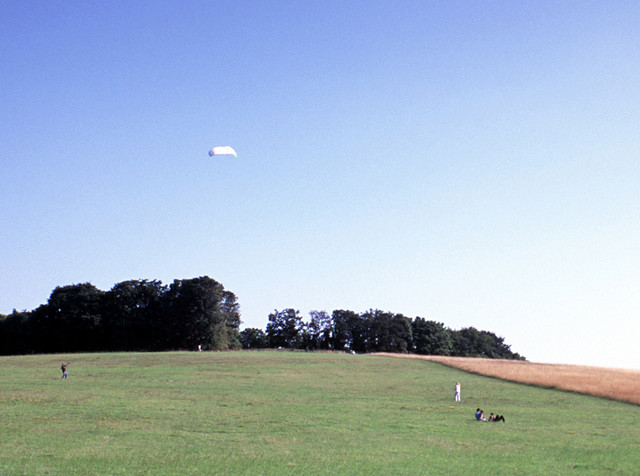What activities can you suggest for this location? Given the spacious and open nature of the field, it's an ideal location for a variety of recreational activities. People could engage in picnicking, flying kites, playing frisbee, team sports like soccer or cricket, or simply enjoying a leisurely walk. The clear skies also offer perfect conditions for flying lightweight model airplanes or drones. 